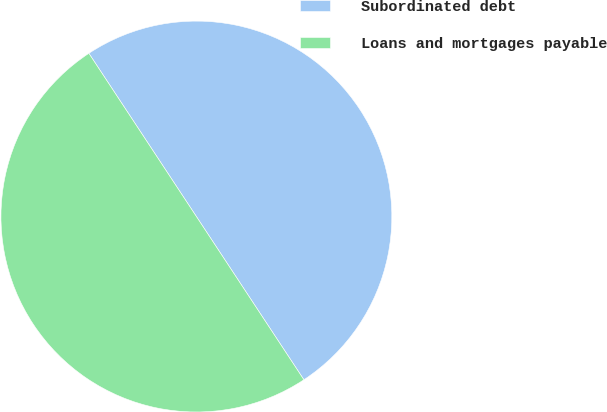<chart> <loc_0><loc_0><loc_500><loc_500><pie_chart><fcel>Subordinated debt<fcel>Loans and mortgages payable<nl><fcel>50.0%<fcel>50.0%<nl></chart> 